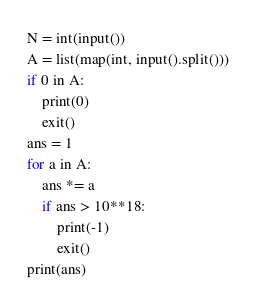<code> <loc_0><loc_0><loc_500><loc_500><_Python_>N = int(input())
A = list(map(int, input().split()))
if 0 in A:
    print(0)
    exit()
ans = 1
for a in A:
    ans *= a
    if ans > 10**18:
        print(-1)
        exit()
print(ans)
</code> 